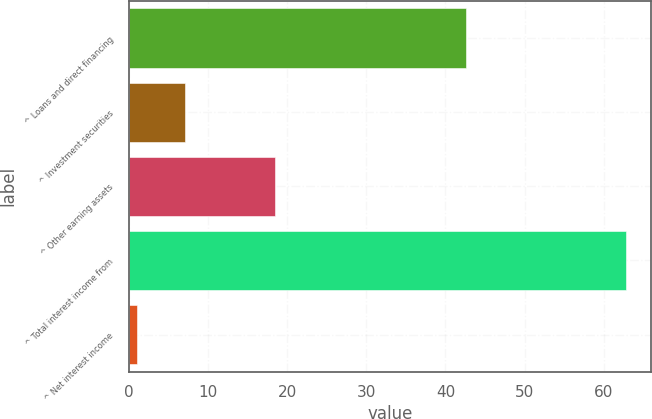Convert chart. <chart><loc_0><loc_0><loc_500><loc_500><bar_chart><fcel>^ Loans and direct financing<fcel>^ Investment securities<fcel>^ Other earning assets<fcel>^ Total interest income from<fcel>^ Net interest income<nl><fcel>42.6<fcel>7.18<fcel>18.5<fcel>62.8<fcel>1<nl></chart> 